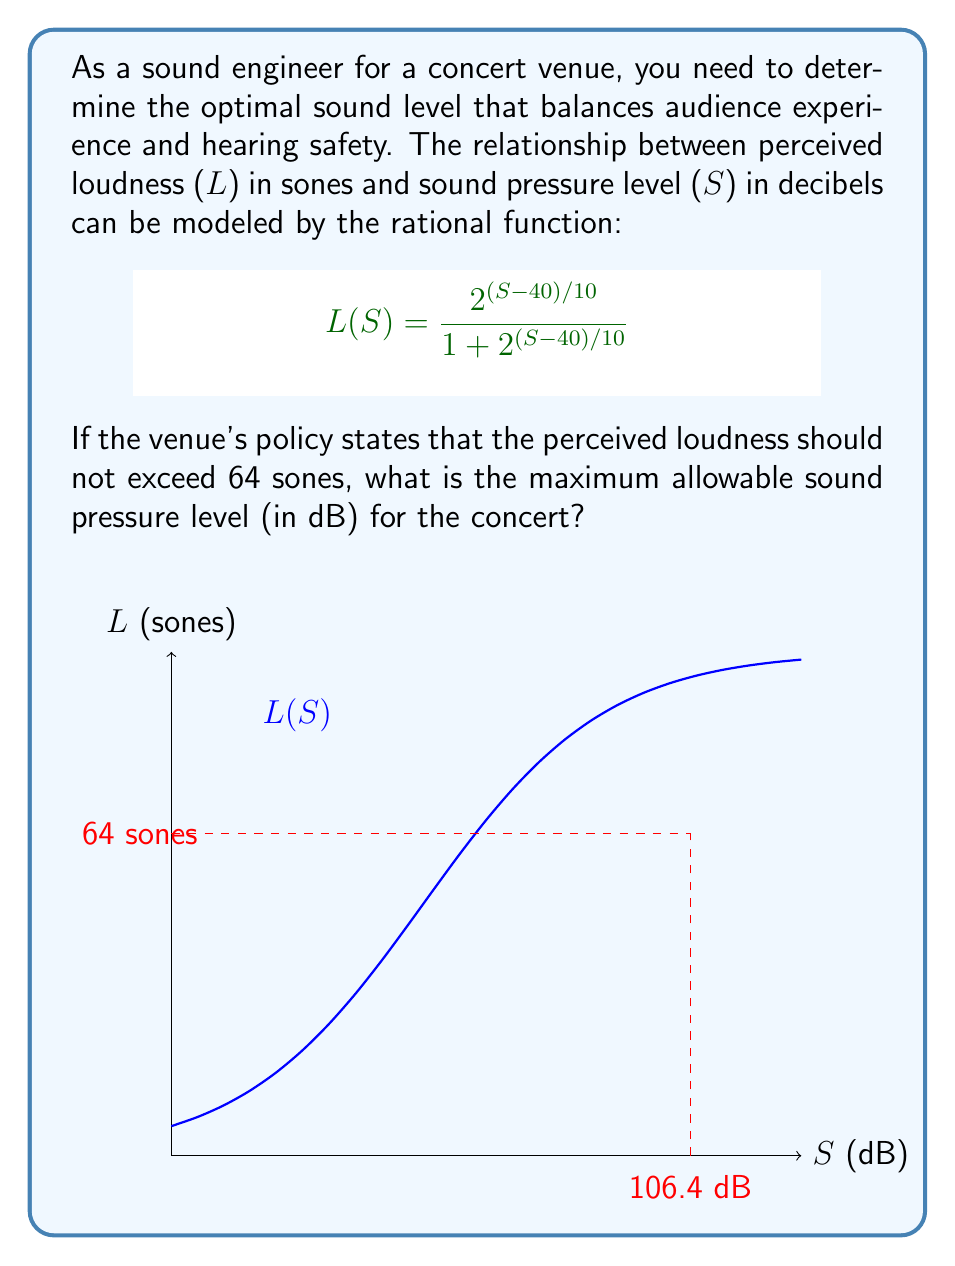What is the answer to this math problem? Let's approach this step-by-step:

1) We need to solve the equation:

   $$\frac{2^{(S-40)/10}}{1 + 2^{(S-40)/10}} = 64$$

2) Let's simplify by setting $x = 2^{(S-40)/10}$:

   $$\frac{x}{1 + x} = 64$$

3) Cross-multiply:

   $$x = 64 + 64x$$

4) Subtract 64x from both sides:

   $$-63x = 64$$

5) Divide both sides by -63:

   $$x = -\frac{64}{63}$$

6) Now, let's solve for S:

   $$2^{(S-40)/10} = -\frac{64}{63}$$

7) Take the logarithm (base 2) of both sides:

   $$\frac{S-40}{10} = \log_2(-\frac{64}{63})$$

8) Multiply both sides by 10:

   $$S-40 = 10 \log_2(-\frac{64}{63})$$

9) Add 40 to both sides:

   $$S = 40 + 10 \log_2(-\frac{64}{63})$$

10) Calculate the result:

    $$S \approx 106.4$$

Therefore, the maximum allowable sound pressure level is approximately 106.4 dB.
Answer: 106.4 dB 